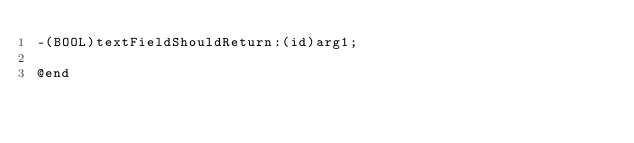Convert code to text. <code><loc_0><loc_0><loc_500><loc_500><_C_>-(BOOL)textFieldShouldReturn:(id)arg1;

@end

</code> 